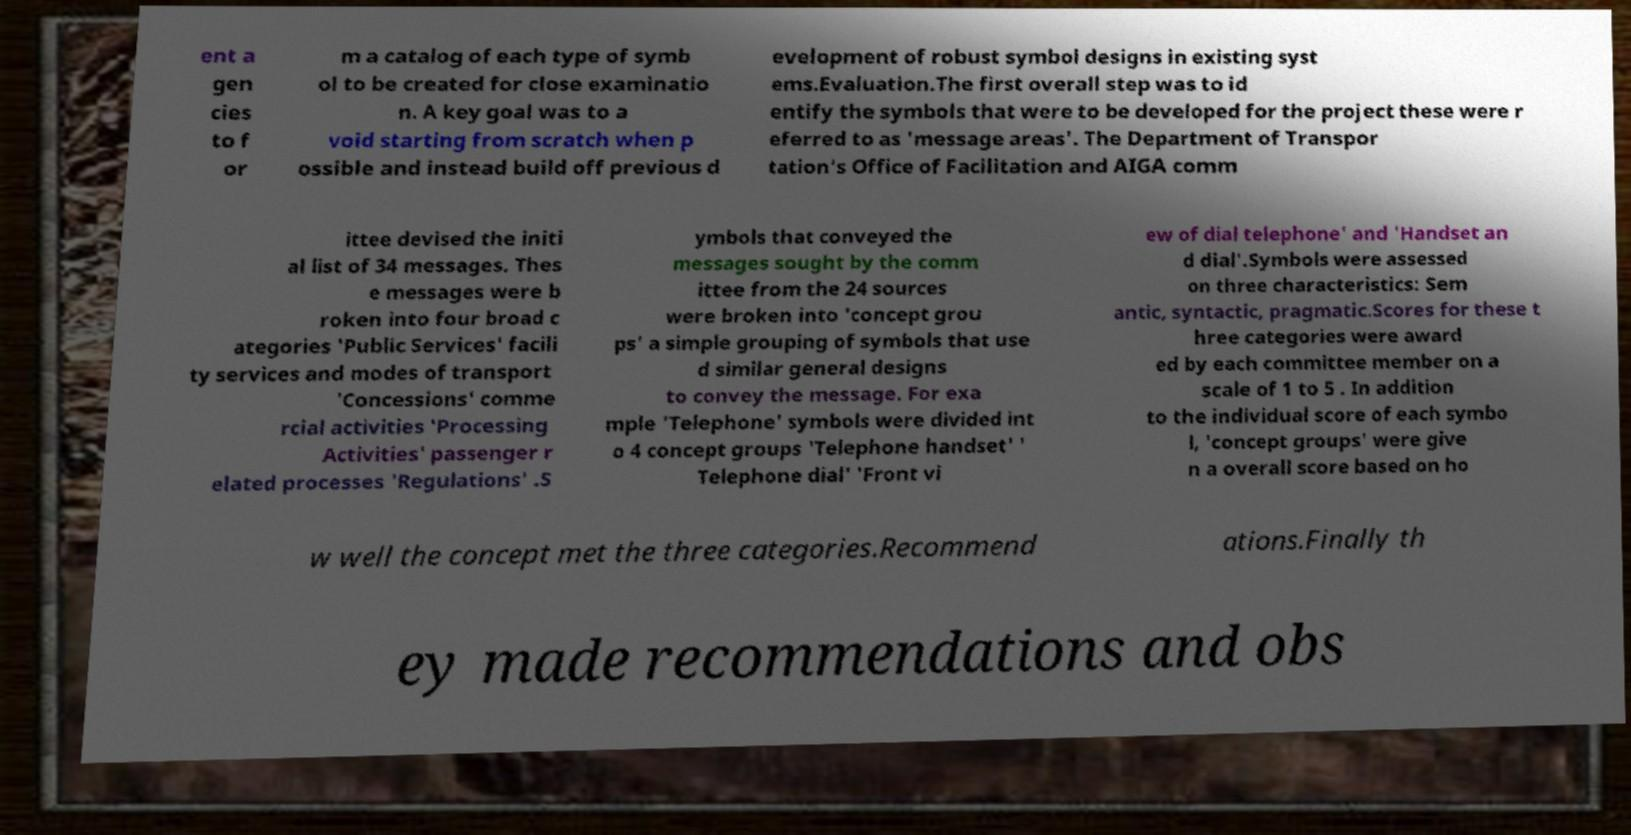Please read and relay the text visible in this image. What does it say? ent a gen cies to f or m a catalog of each type of symb ol to be created for close examinatio n. A key goal was to a void starting from scratch when p ossible and instead build off previous d evelopment of robust symbol designs in existing syst ems.Evaluation.The first overall step was to id entify the symbols that were to be developed for the project these were r eferred to as 'message areas'. The Department of Transpor tation's Office of Facilitation and AIGA comm ittee devised the initi al list of 34 messages. Thes e messages were b roken into four broad c ategories 'Public Services' facili ty services and modes of transport 'Concessions' comme rcial activities 'Processing Activities' passenger r elated processes 'Regulations' .S ymbols that conveyed the messages sought by the comm ittee from the 24 sources were broken into 'concept grou ps' a simple grouping of symbols that use d similar general designs to convey the message. For exa mple 'Telephone' symbols were divided int o 4 concept groups 'Telephone handset' ' Telephone dial' 'Front vi ew of dial telephone' and 'Handset an d dial'.Symbols were assessed on three characteristics: Sem antic, syntactic, pragmatic.Scores for these t hree categories were award ed by each committee member on a scale of 1 to 5 . In addition to the individual score of each symbo l, 'concept groups' were give n a overall score based on ho w well the concept met the three categories.Recommend ations.Finally th ey made recommendations and obs 